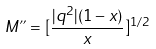Convert formula to latex. <formula><loc_0><loc_0><loc_500><loc_500>M " = [ \frac { | q ^ { 2 } | ( 1 - x ) } { x } ] ^ { 1 / 2 }</formula> 